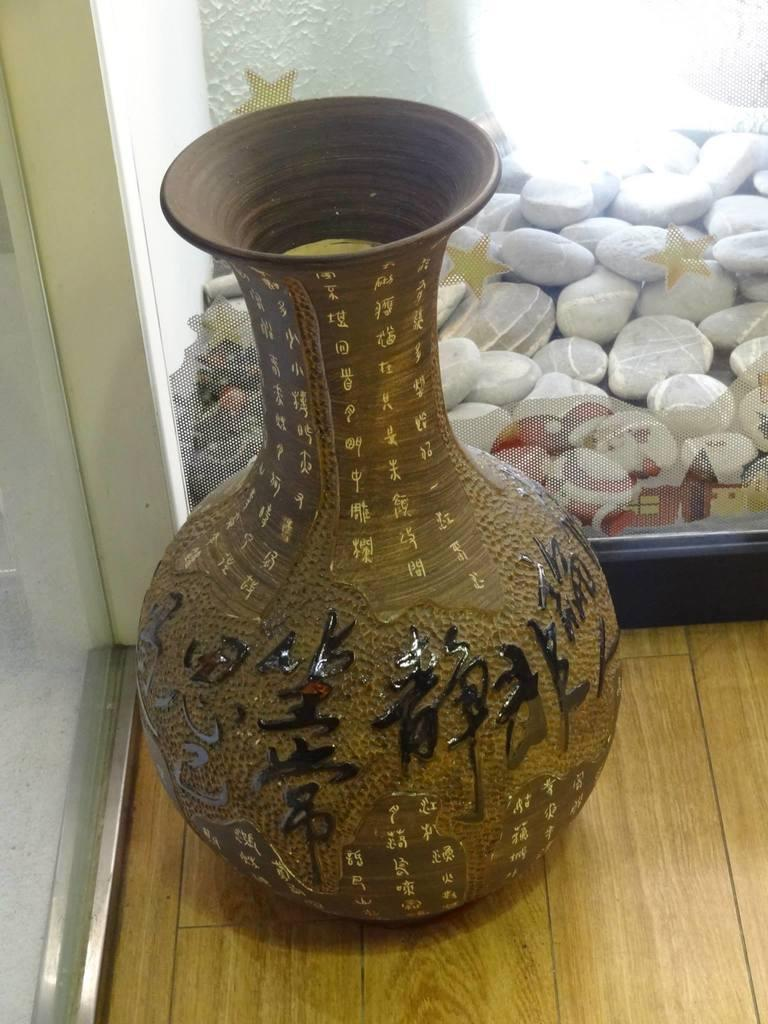What is the main object in the foreground of the image? There is a flower vase in the foreground of the image. What might be the material of the surface beneath the flower vase? The flower vase might be on a wooden floor. What is beside the flower vase in the image? There is a glass window beside the flower vase. What can be seen through the glass window? Stones are visible through the window. What type of heart-shaped paste is visible on the window? There is no heart-shaped paste present in the image. 